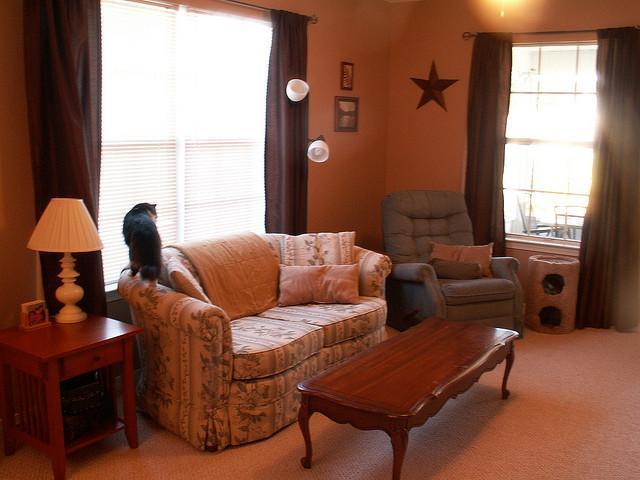How many couches are there?
Give a very brief answer. 2. 